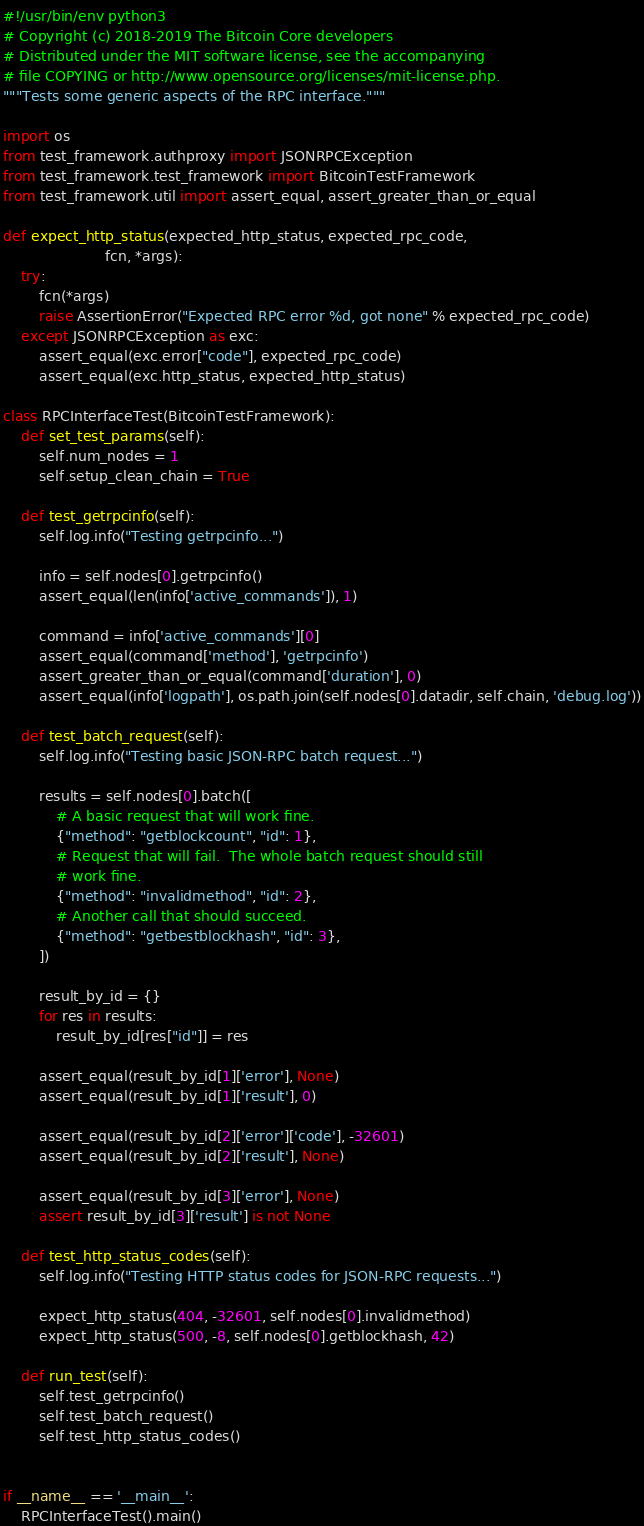<code> <loc_0><loc_0><loc_500><loc_500><_Python_>#!/usr/bin/env python3
# Copyright (c) 2018-2019 The Bitcoin Core developers
# Distributed under the MIT software license, see the accompanying
# file COPYING or http://www.opensource.org/licenses/mit-license.php.
"""Tests some generic aspects of the RPC interface."""

import os
from test_framework.authproxy import JSONRPCException
from test_framework.test_framework import BitcoinTestFramework
from test_framework.util import assert_equal, assert_greater_than_or_equal

def expect_http_status(expected_http_status, expected_rpc_code,
                       fcn, *args):
    try:
        fcn(*args)
        raise AssertionError("Expected RPC error %d, got none" % expected_rpc_code)
    except JSONRPCException as exc:
        assert_equal(exc.error["code"], expected_rpc_code)
        assert_equal(exc.http_status, expected_http_status)

class RPCInterfaceTest(BitcoinTestFramework):
    def set_test_params(self):
        self.num_nodes = 1
        self.setup_clean_chain = True

    def test_getrpcinfo(self):
        self.log.info("Testing getrpcinfo...")

        info = self.nodes[0].getrpcinfo()
        assert_equal(len(info['active_commands']), 1)

        command = info['active_commands'][0]
        assert_equal(command['method'], 'getrpcinfo')
        assert_greater_than_or_equal(command['duration'], 0)
        assert_equal(info['logpath'], os.path.join(self.nodes[0].datadir, self.chain, 'debug.log'))

    def test_batch_request(self):
        self.log.info("Testing basic JSON-RPC batch request...")

        results = self.nodes[0].batch([
            # A basic request that will work fine.
            {"method": "getblockcount", "id": 1},
            # Request that will fail.  The whole batch request should still
            # work fine.
            {"method": "invalidmethod", "id": 2},
            # Another call that should succeed.
            {"method": "getbestblockhash", "id": 3},
        ])

        result_by_id = {}
        for res in results:
            result_by_id[res["id"]] = res

        assert_equal(result_by_id[1]['error'], None)
        assert_equal(result_by_id[1]['result'], 0)

        assert_equal(result_by_id[2]['error']['code'], -32601)
        assert_equal(result_by_id[2]['result'], None)

        assert_equal(result_by_id[3]['error'], None)
        assert result_by_id[3]['result'] is not None

    def test_http_status_codes(self):
        self.log.info("Testing HTTP status codes for JSON-RPC requests...")

        expect_http_status(404, -32601, self.nodes[0].invalidmethod)
        expect_http_status(500, -8, self.nodes[0].getblockhash, 42)

    def run_test(self):
        self.test_getrpcinfo()
        self.test_batch_request()
        self.test_http_status_codes()


if __name__ == '__main__':
    RPCInterfaceTest().main()
</code> 